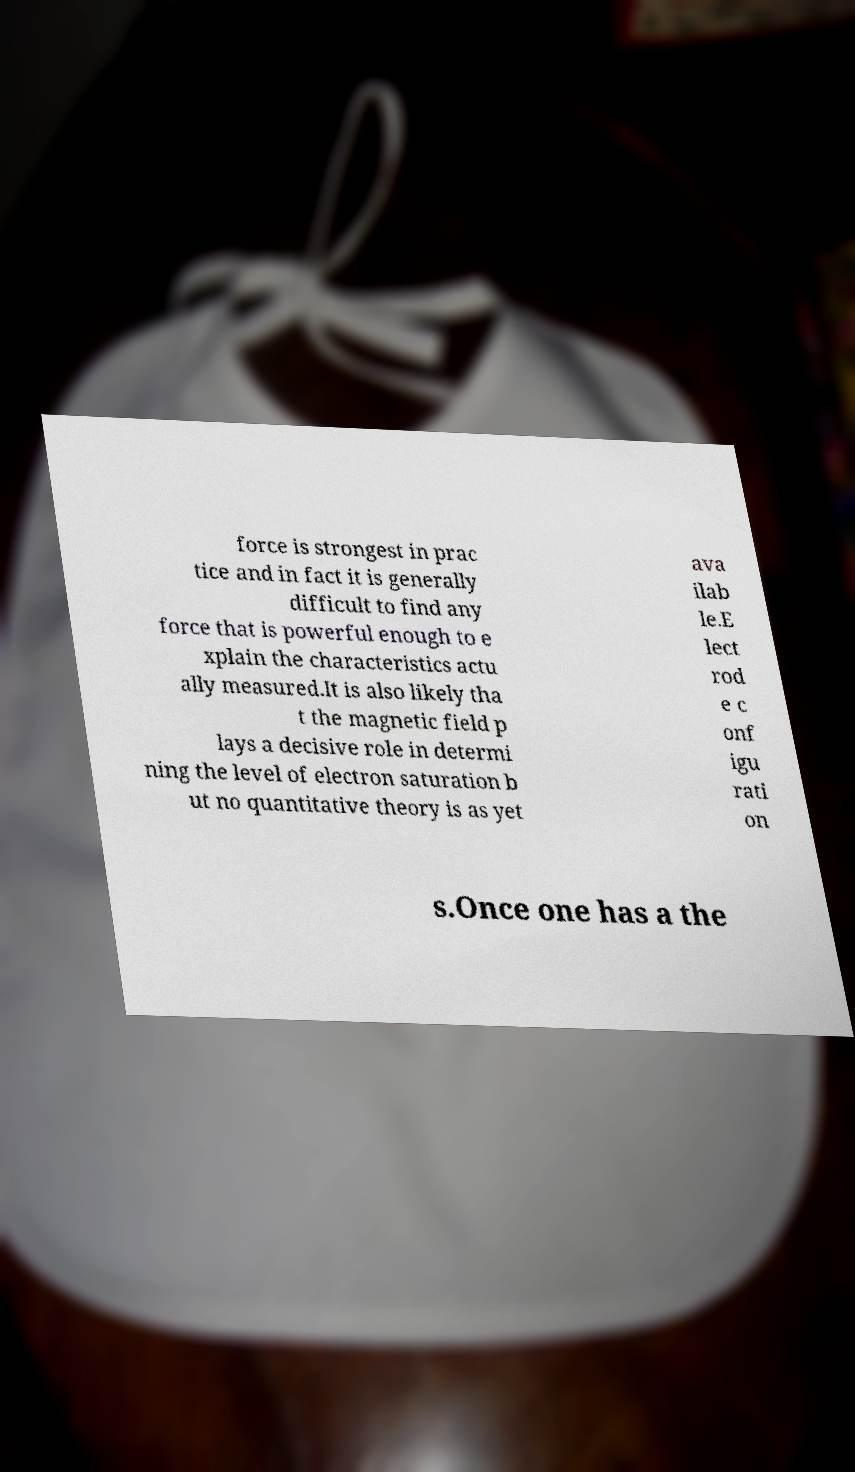Please identify and transcribe the text found in this image. force is strongest in prac tice and in fact it is generally difficult to find any force that is powerful enough to e xplain the characteristics actu ally measured.It is also likely tha t the magnetic field p lays a decisive role in determi ning the level of electron saturation b ut no quantitative theory is as yet ava ilab le.E lect rod e c onf igu rati on s.Once one has a the 